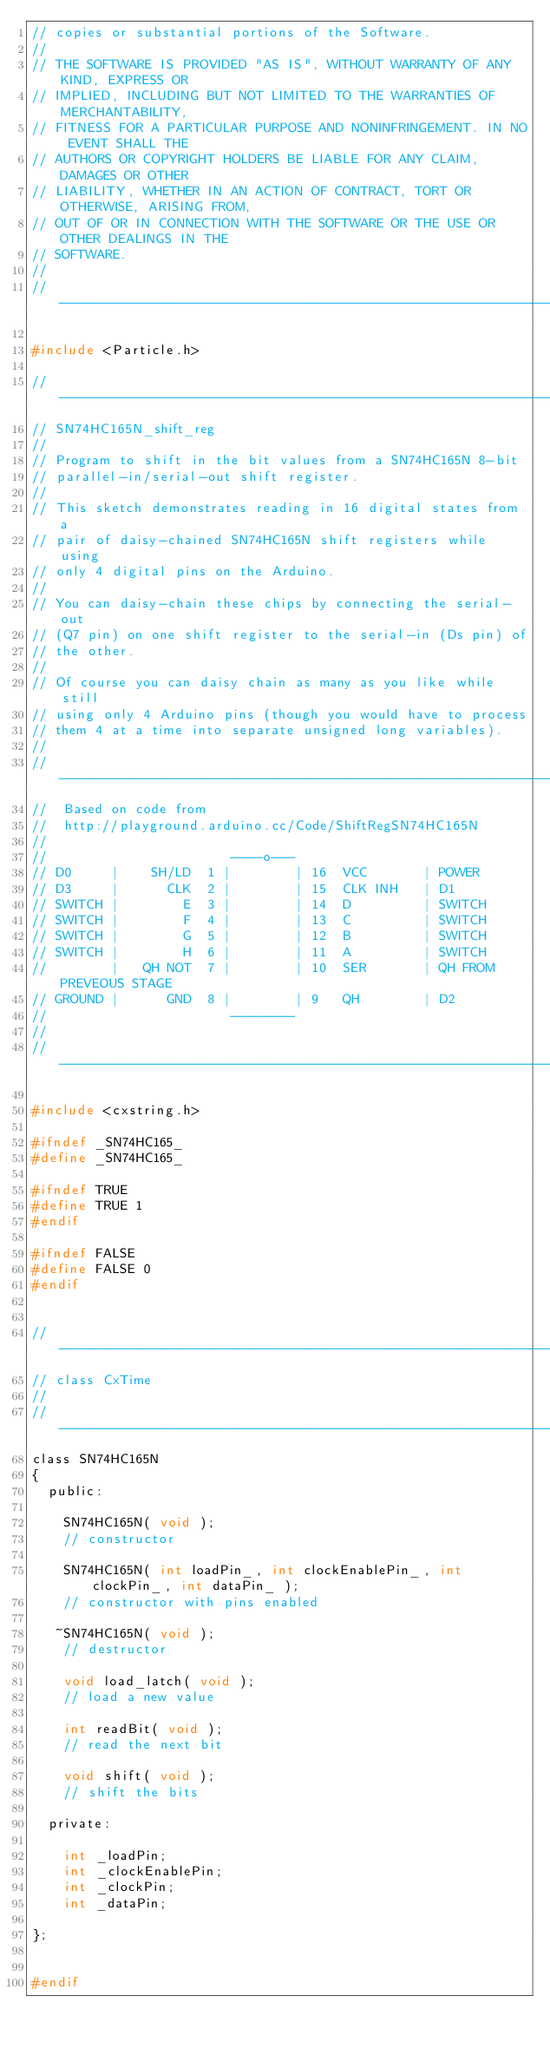<code> <loc_0><loc_0><loc_500><loc_500><_C_>// copies or substantial portions of the Software.
// 
// THE SOFTWARE IS PROVIDED "AS IS", WITHOUT WARRANTY OF ANY KIND, EXPRESS OR
// IMPLIED, INCLUDING BUT NOT LIMITED TO THE WARRANTIES OF MERCHANTABILITY,
// FITNESS FOR A PARTICULAR PURPOSE AND NONINFRINGEMENT. IN NO EVENT SHALL THE
// AUTHORS OR COPYRIGHT HOLDERS BE LIABLE FOR ANY CLAIM, DAMAGES OR OTHER
// LIABILITY, WHETHER IN AN ACTION OF CONTRACT, TORT OR OTHERWISE, ARISING FROM,
// OUT OF OR IN CONNECTION WITH THE SOFTWARE OR THE USE OR OTHER DEALINGS IN THE
// SOFTWARE.
//
//------------------------------------------------------------------------------------------------------------

#include <Particle.h>

//------------------------------------------------------------------------------------------------------------
// SN74HC165N_shift_reg
//
// Program to shift in the bit values from a SN74HC165N 8-bit
// parallel-in/serial-out shift register.
//
// This sketch demonstrates reading in 16 digital states from a
// pair of daisy-chained SN74HC165N shift registers while using
// only 4 digital pins on the Arduino.
//
// You can daisy-chain these chips by connecting the serial-out
// (Q7 pin) on one shift register to the serial-in (Ds pin) of
// the other.
// 
// Of course you can daisy chain as many as you like while still
// using only 4 Arduino pins (though you would have to process
// them 4 at a time into separate unsigned long variables).
//
//------------------------------------------------------------------------------------------------------------
//  Based on code from
//  http://playground.arduino.cc/Code/ShiftRegSN74HC165N
//
//                       ----o---
// D0     |    SH/LD  1 |        | 16  VCC       | POWER
// D3     |      CLK  2 |        | 15  CLK INH   | D1
// SWITCH |        E  3 |        | 14  D         | SWITCH
// SWITCH |        F  4 |        | 13  C         | SWITCH
// SWITCH |        G  5 |        | 12  B         | SWITCH
// SWITCH |        H  6 |        | 11  A         | SWITCH
//        |   QH NOT  7 |        | 10  SER       | QH FROM PREVEOUS STAGE
// GROUND |      GND  8 |        | 9   QH        | D2
//                       --------
//
//------------------------------------------------------------------------------------------------------------

#include <cxstring.h>

#ifndef _SN74HC165_
#define _SN74HC165_

#ifndef TRUE
#define TRUE 1
#endif

#ifndef FALSE
#define FALSE 0
#endif


//------------------------------------------------------------------------------------------------------------
// class CxTime
//
//------------------------------------------------------------------------------------------------------------
class SN74HC165N
{
  public:
  
    SN74HC165N( void );
    // constructor

	SN74HC165N( int loadPin_, int clockEnablePin_, int clockPin_, int dataPin_ );
	// constructor with pins enabled

   ~SN74HC165N( void );
	// destructor

    void load_latch( void );
    // load a new value
    
    int readBit( void );
    // read the next bit
    
    void shift( void );
    // shift the bits
    
  private:

    int _loadPin;
    int _clockEnablePin;
    int _clockPin;
    int _dataPin; 
 
};


#endif

</code> 